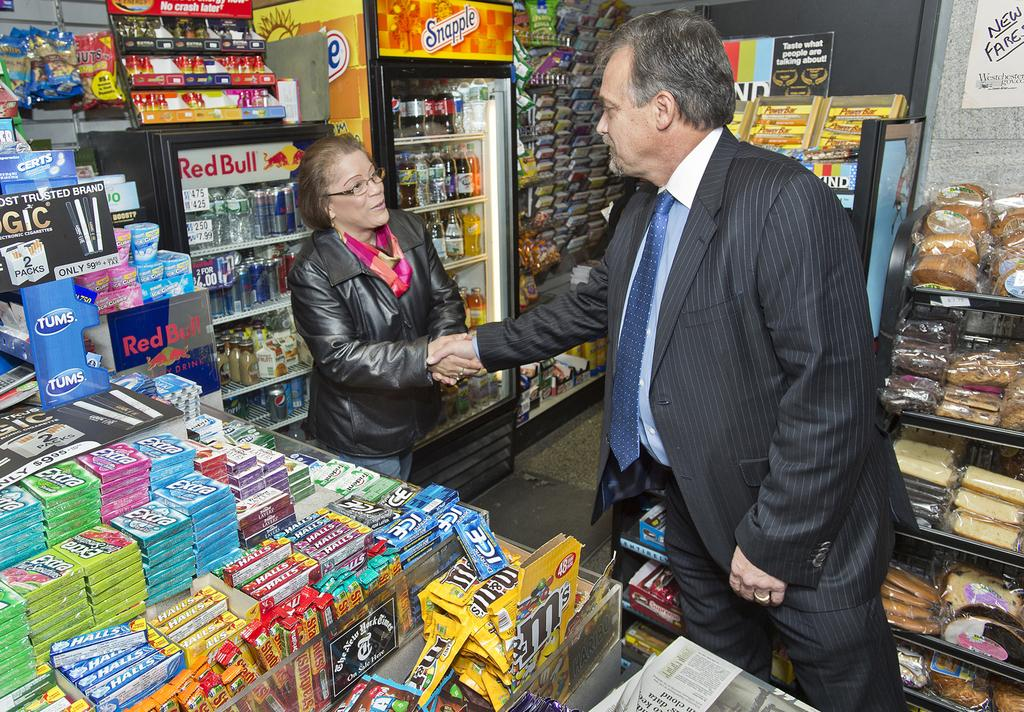Provide a one-sentence caption for the provided image. A man in a suit shakes the hand of woman standing in front of a red bull branded fridge. 